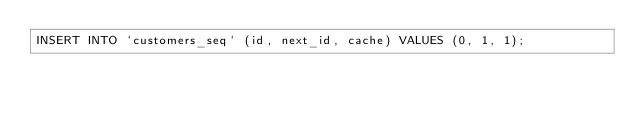<code> <loc_0><loc_0><loc_500><loc_500><_SQL_>INSERT INTO `customers_seq` (id, next_id, cache) VALUES (0, 1, 1);
</code> 